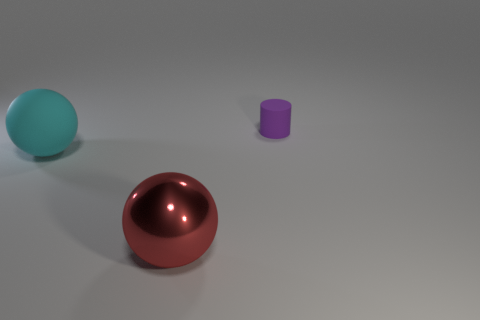The big thing that is to the left of the ball in front of the big cyan rubber sphere is made of what material? The object to the left of the ball appears to be a cylindrical shape with a matte surface, suggesting that it could be made of a plastic material. 